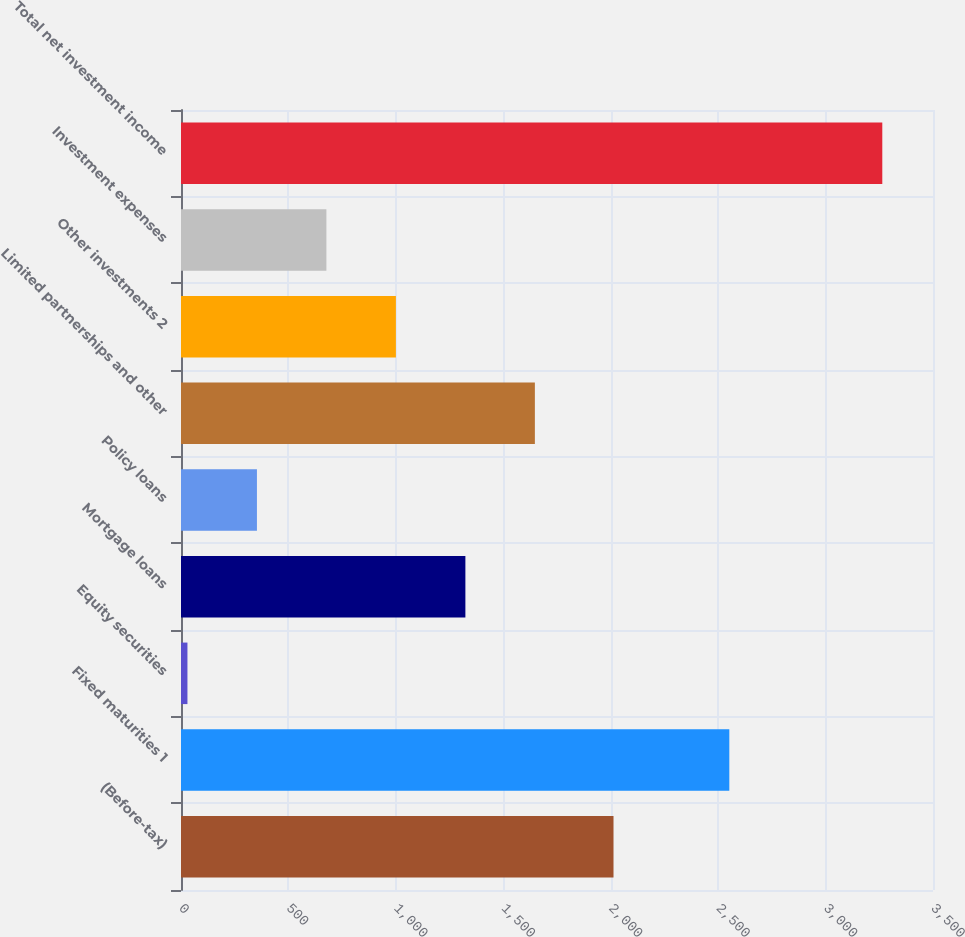<chart> <loc_0><loc_0><loc_500><loc_500><bar_chart><fcel>(Before-tax)<fcel>Fixed maturities 1<fcel>Equity securities<fcel>Mortgage loans<fcel>Policy loans<fcel>Limited partnerships and other<fcel>Other investments 2<fcel>Investment expenses<fcel>Total net investment income<nl><fcel>2013<fcel>2552<fcel>30<fcel>1323.6<fcel>353.4<fcel>1647<fcel>1000.2<fcel>676.8<fcel>3264<nl></chart> 